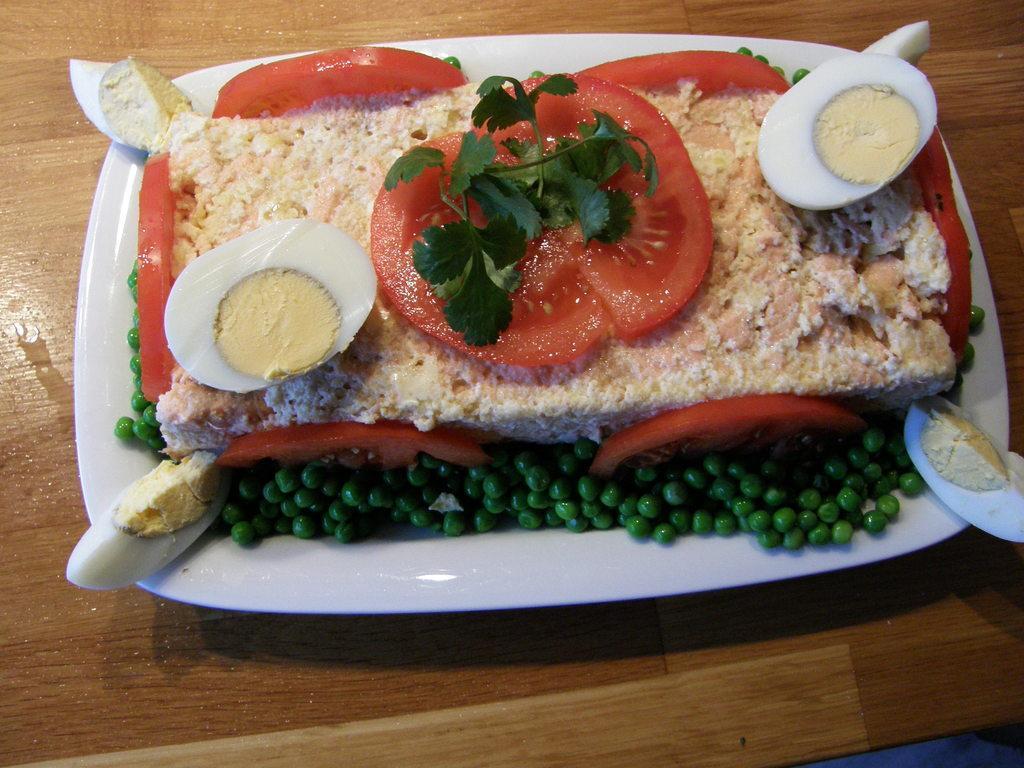In one or two sentences, can you explain what this image depicts? In this image, we can see a plate on the table contains some food. 